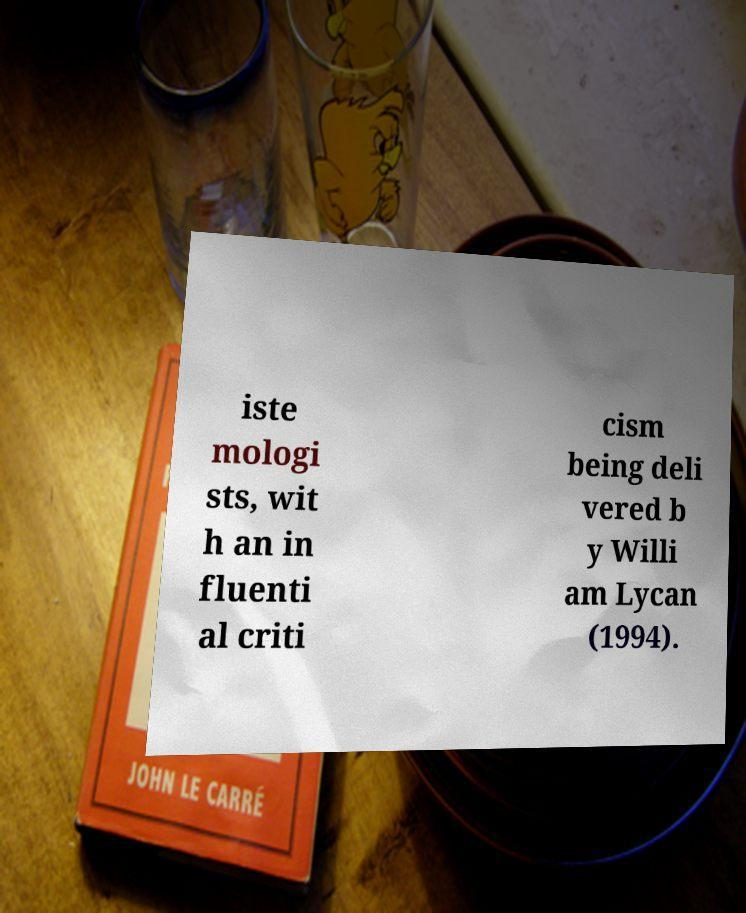There's text embedded in this image that I need extracted. Can you transcribe it verbatim? iste mologi sts, wit h an in fluenti al criti cism being deli vered b y Willi am Lycan (1994). 